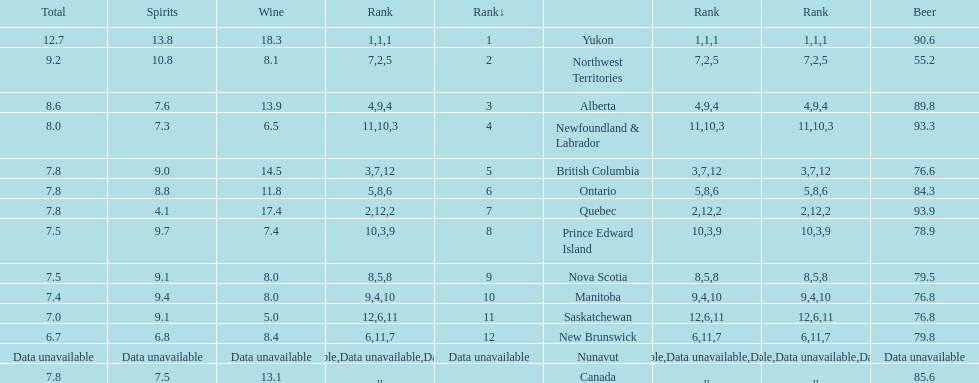What are the number of territories that have a wine consumption above 10.0? 5. 